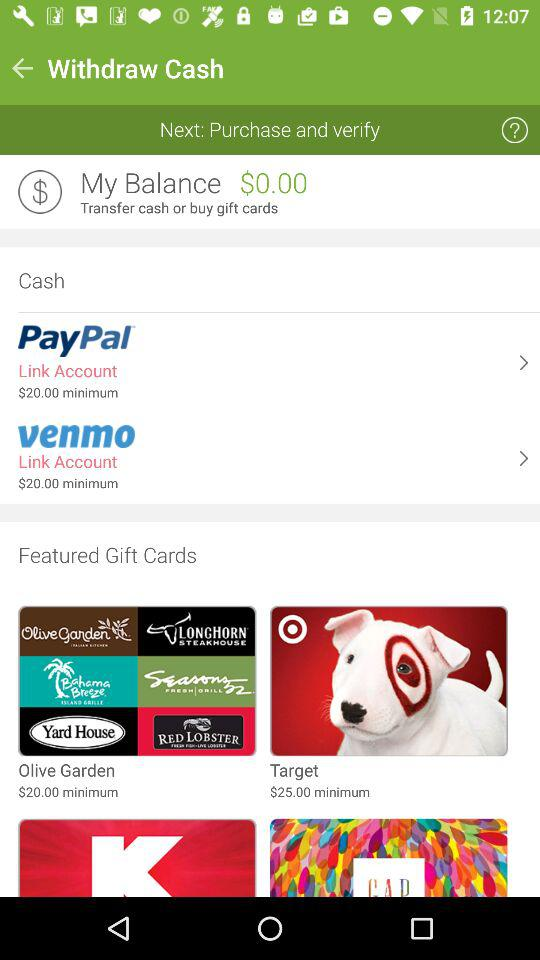What is the balance? The balance is $0.00. 